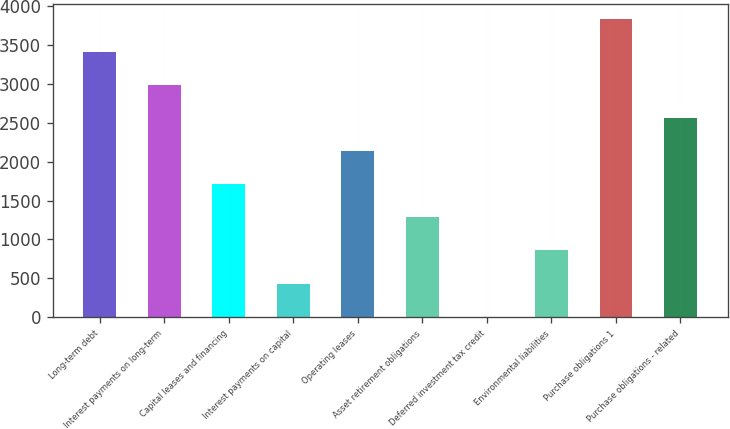<chart> <loc_0><loc_0><loc_500><loc_500><bar_chart><fcel>Long-term debt<fcel>Interest payments on long-term<fcel>Capital leases and financing<fcel>Interest payments on capital<fcel>Operating leases<fcel>Asset retirement obligations<fcel>Deferred investment tax credit<fcel>Environmental liabilities<fcel>Purchase obligations 1<fcel>Purchase obligations - related<nl><fcel>3415.6<fcel>2989.4<fcel>1710.8<fcel>432.2<fcel>2137<fcel>1284.6<fcel>6<fcel>858.4<fcel>3841.8<fcel>2563.2<nl></chart> 